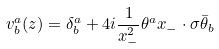Convert formula to latex. <formula><loc_0><loc_0><loc_500><loc_500>v _ { b } ^ { a } ( z ) = \delta _ { b } ^ { a } + 4 i \frac { 1 } { x _ { - } ^ { 2 } } \theta ^ { a } x _ { - } \cdot \sigma \bar { \theta } _ { b }</formula> 